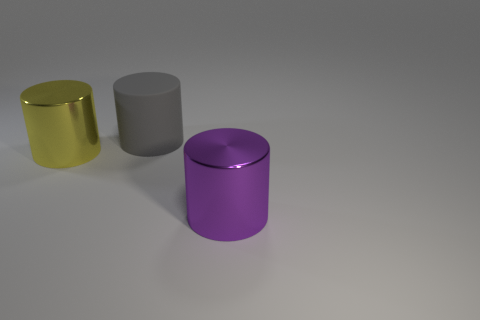Is there anything else that has the same material as the gray object?
Provide a succinct answer. No. Do the gray thing and the big shiny thing behind the purple metal cylinder have the same shape?
Your answer should be very brief. Yes. What is the shape of the big purple thing?
Make the answer very short. Cylinder. There is a gray cylinder that is the same size as the yellow object; what material is it?
Ensure brevity in your answer.  Rubber. Is there any other thing that has the same size as the rubber cylinder?
Provide a short and direct response. Yes. How many objects are large brown shiny things or things in front of the large rubber thing?
Give a very brief answer. 2. There is a cylinder that is the same material as the purple thing; what is its size?
Keep it short and to the point. Large. There is a thing that is to the left of the purple metallic cylinder and in front of the gray rubber thing; what size is it?
Your answer should be compact. Large. Are there any large purple things of the same shape as the big gray object?
Keep it short and to the point. Yes. Are there any other things that are the same shape as the big gray rubber object?
Your response must be concise. Yes. 